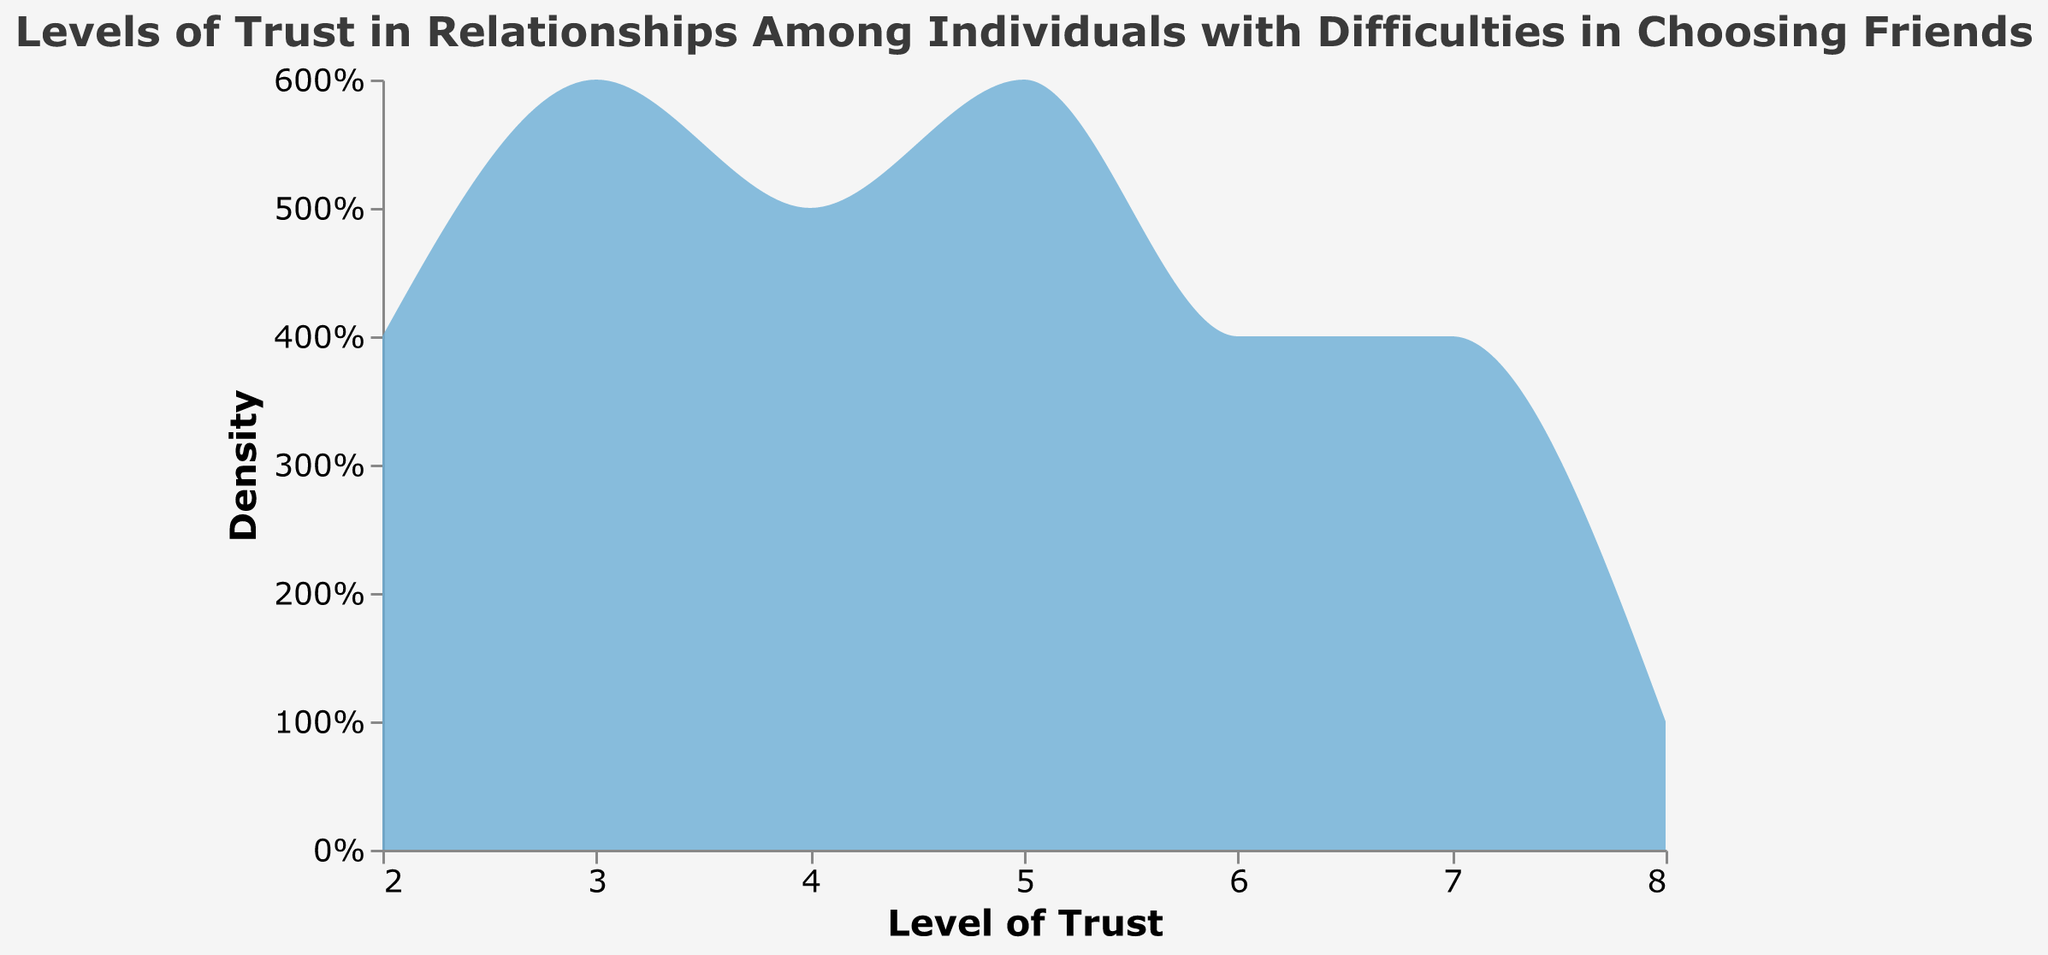what is the title of the figure? The title of the figure is displayed at the top, indicating what the data represents which helps in understanding the context. It reads: "Levels of Trust in Relationships Among Individuals with Difficulties in Choosing Friends".
Answer: Levels of Trust in Relationships Among Individuals with Difficulties in Choosing Friends how many persons have a trust level of 2? To determine this, look at the density plot and observe the count for the trust level 2 on the x-axis. The y-axis value shows the density. Trust level 2 appears 4 times.
Answer: 4 what trust level appears most frequently? By analyzing the height of density areas, identify the x-axis level (trust level) with the highest peak. The densest part of the plot indicates the most frequent trust level. Trust level 3 appears most frequently.
Answer: 3 how many unique trust levels are represented? Examine the x-axis to count distinct trust levels present in the data. Counting them reveals 7 unique trust levels: 2, 3, 4, 5, 6, 7, and 8.
Answer: 7 what is the least frequent trust level? Observe the density plot and determine the trust level with the smallest peak (least height). Trust level 8 has the least frequency in this dataset.
Answer: 8 what is the range of trust levels? The range of values can be found by determining the minimum and maximum values on the x-axis, which represent levels of trust. Here the range spans from 2 to 8.
Answer: 2 to 8 what can you say about the distribution of trust levels? Assess the trend shown by the density plot’s shape. It appears that the trust levels are not uniformly distributed; lower levels (2-4) have higher frequency peaks, suggesting many individuals have lower levels of trust in relationships.
Answer: Lower levels (2-4) have higher frequency which trust levels have a normalized density above 0.15 when aggregated? To identify this, examine the plot and track the levels where the density exceeds 0.15. Trust levels 3, 4, and 5 have normalized densities above 0.15.
Answer: 3, 4, 5 